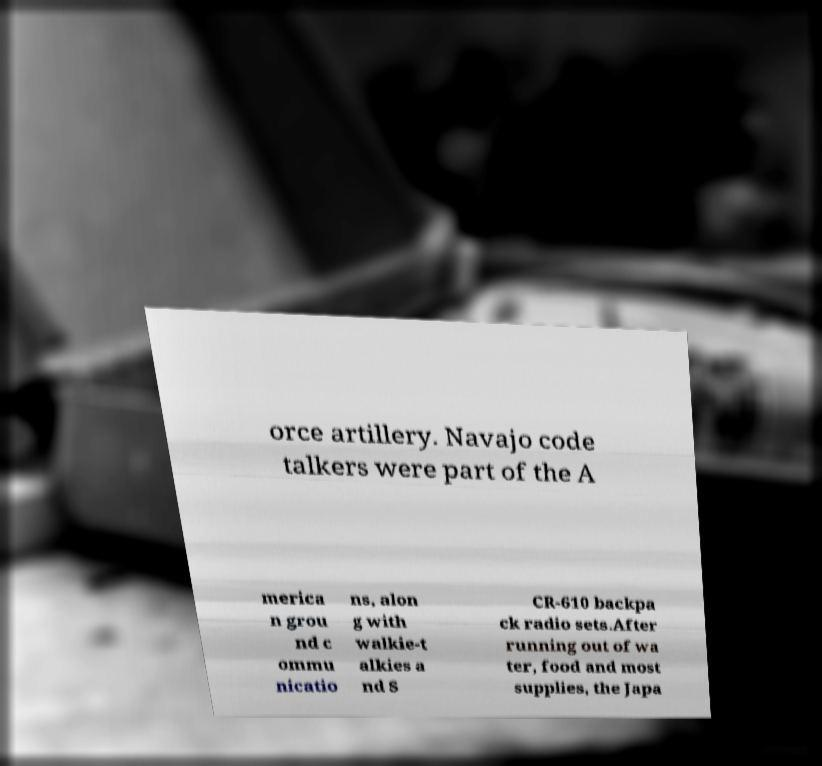Please read and relay the text visible in this image. What does it say? orce artillery. Navajo code talkers were part of the A merica n grou nd c ommu nicatio ns, alon g with walkie-t alkies a nd S CR-610 backpa ck radio sets.After running out of wa ter, food and most supplies, the Japa 